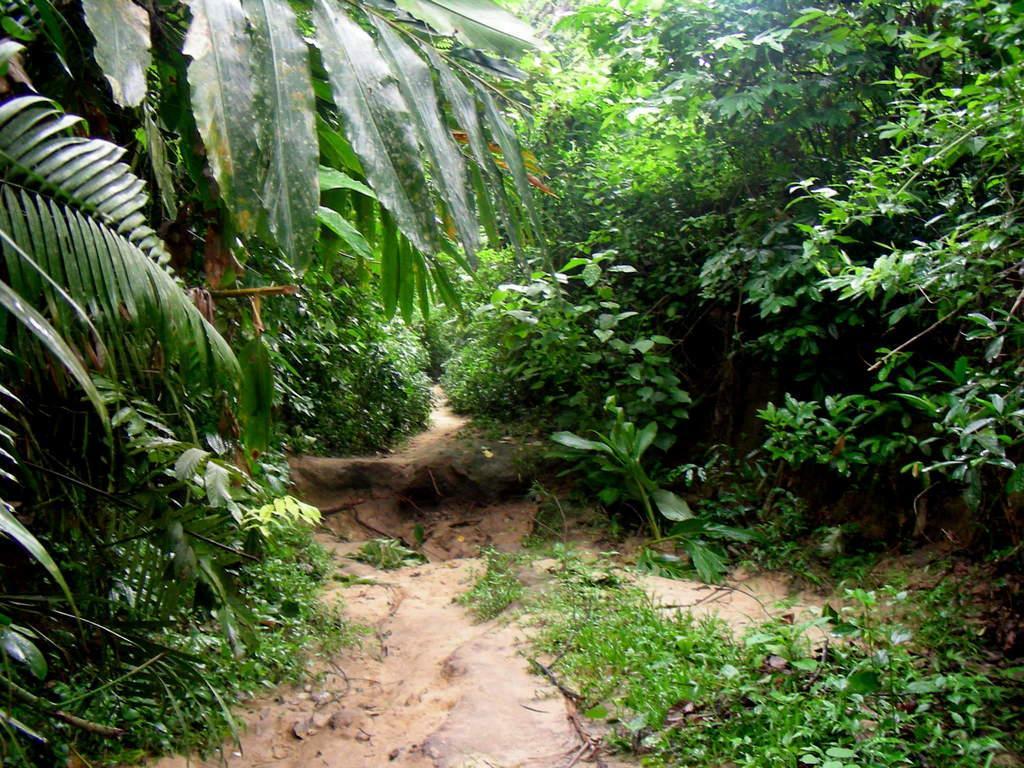Describe this image in one or two sentences. In this image we can see the plants, grass and also the trees. We can also see the ground. 